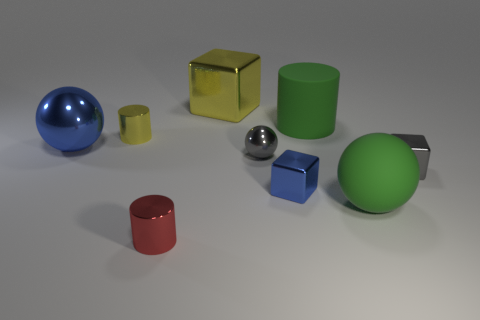Is the number of small blue things greater than the number of green objects?
Offer a very short reply. No. Is there anything else that has the same color as the large block?
Make the answer very short. Yes. Is the material of the small red cylinder the same as the tiny ball?
Provide a short and direct response. Yes. Are there fewer small spheres than tiny metallic cubes?
Provide a succinct answer. Yes. Is the big blue thing the same shape as the small yellow metal object?
Your answer should be compact. No. What is the color of the tiny metal ball?
Your response must be concise. Gray. How many other things are made of the same material as the yellow cylinder?
Your answer should be compact. 6. How many gray objects are cylinders or tiny shiny cylinders?
Offer a terse response. 0. There is a metallic thing on the right side of the green sphere; does it have the same shape as the large green thing behind the blue metal block?
Offer a very short reply. No. Does the large cylinder have the same color as the small shiny cylinder left of the tiny red object?
Offer a very short reply. No. 